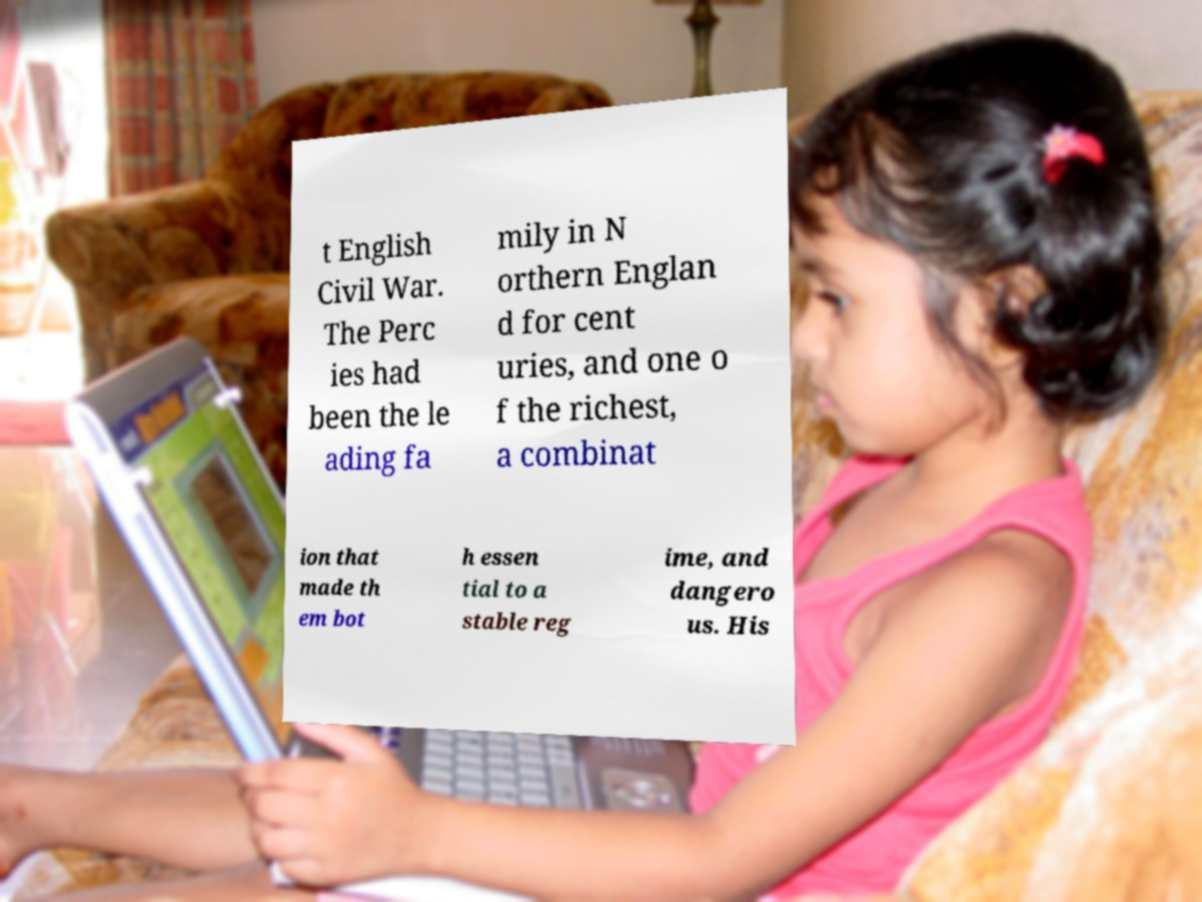Could you assist in decoding the text presented in this image and type it out clearly? t English Civil War. The Perc ies had been the le ading fa mily in N orthern Englan d for cent uries, and one o f the richest, a combinat ion that made th em bot h essen tial to a stable reg ime, and dangero us. His 